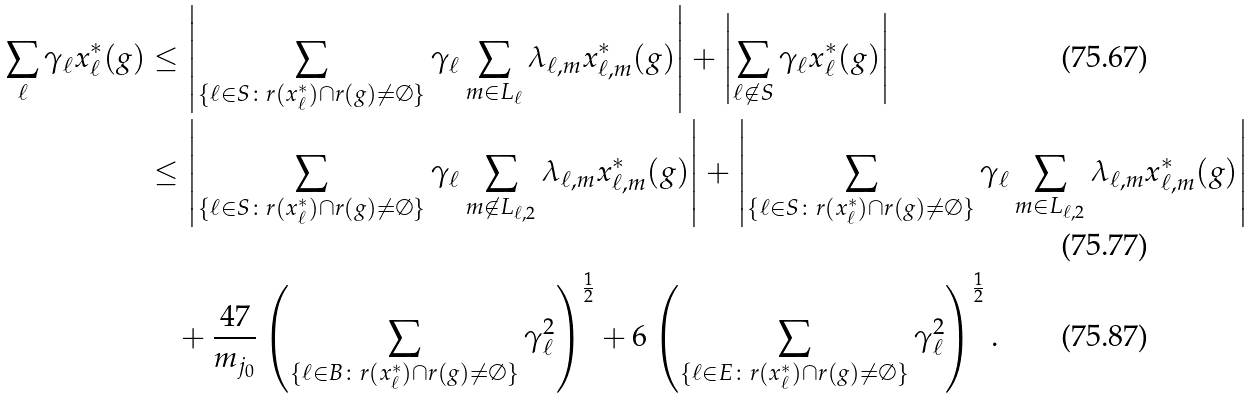<formula> <loc_0><loc_0><loc_500><loc_500>\sum _ { \ell } \gamma _ { \ell } x ^ { * } _ { \ell } ( g ) & \leq \left | \sum _ { \{ \ell \in S \colon r ( x ^ { * } _ { \ell } ) \cap r ( g ) \not = \emptyset \} } \gamma _ { \ell } \sum _ { m \in L _ { \ell } } \lambda _ { \ell , m } x ^ { * } _ { \ell , m } ( g ) \right | + \left | \sum _ { \ell \not \in S } \gamma _ { \ell } x ^ { * } _ { \ell } ( g ) \right | \\ & \leq \left | \sum _ { \{ \ell \in S \colon r ( x ^ { * } _ { \ell } ) \cap r ( g ) \not = \emptyset \} } \gamma _ { \ell } \sum _ { m \not \in L _ { \ell , 2 } } \lambda _ { \ell , m } x ^ { * } _ { \ell , m } ( g ) \right | + \left | \sum _ { \{ \ell \in S \colon r ( x ^ { * } _ { \ell } ) \cap r ( g ) \not = \emptyset \} } \gamma _ { \ell } \sum _ { m \in L _ { \ell , 2 } } \lambda _ { \ell , m } x ^ { * } _ { \ell , m } ( g ) \right | \\ & \quad + \frac { 4 7 } { m _ { j _ { 0 } } } \left ( \sum _ { \{ \ell \in B \colon r ( x ^ { * } _ { \ell } ) \cap r ( g ) \not = \emptyset \} } \gamma _ { \ell } ^ { 2 } \right ) ^ { \frac { 1 } { 2 } } + 6 \left ( \sum _ { \{ \ell \in E \colon r ( x ^ { * } _ { \ell } ) \cap r ( g ) \not = \emptyset \} } \gamma _ { \ell } ^ { 2 } \right ) ^ { \frac { 1 } { 2 } } .</formula> 